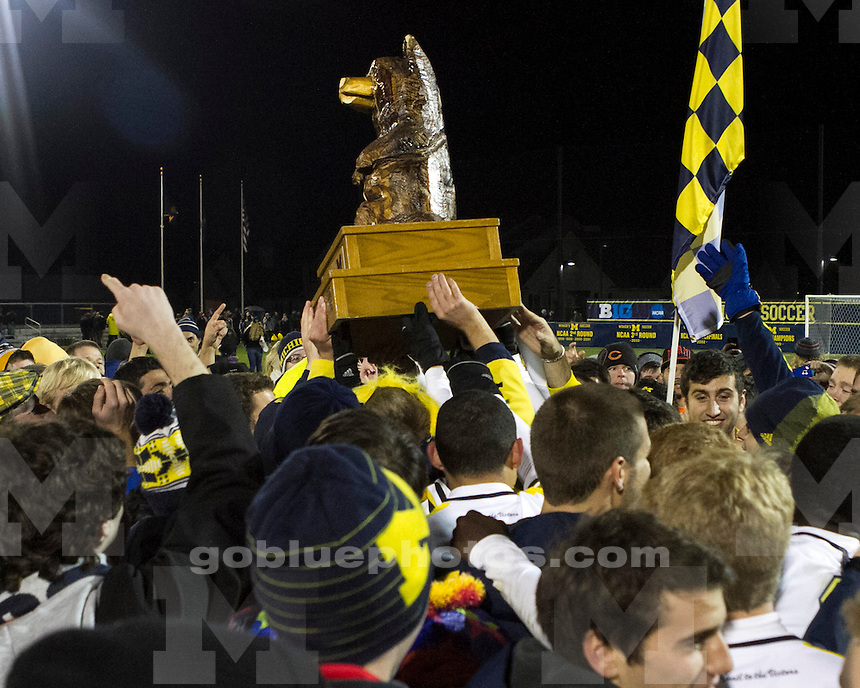Can you describe the atmosphere and emotions visible among the people in the image? The image displays a vibrant and celebratory atmosphere, marked by a crowd of people jubilantly raising their hands and some holding a large golden trophy aloft. The faces of the individuals reflect a blend of exhilaration, pride, and collective happiness, indicative of a significant accomplishment, most likely in the realm of sports. The emotions running through the crowd are those of triumph and unity, as they partake in a shared moment of joy. 